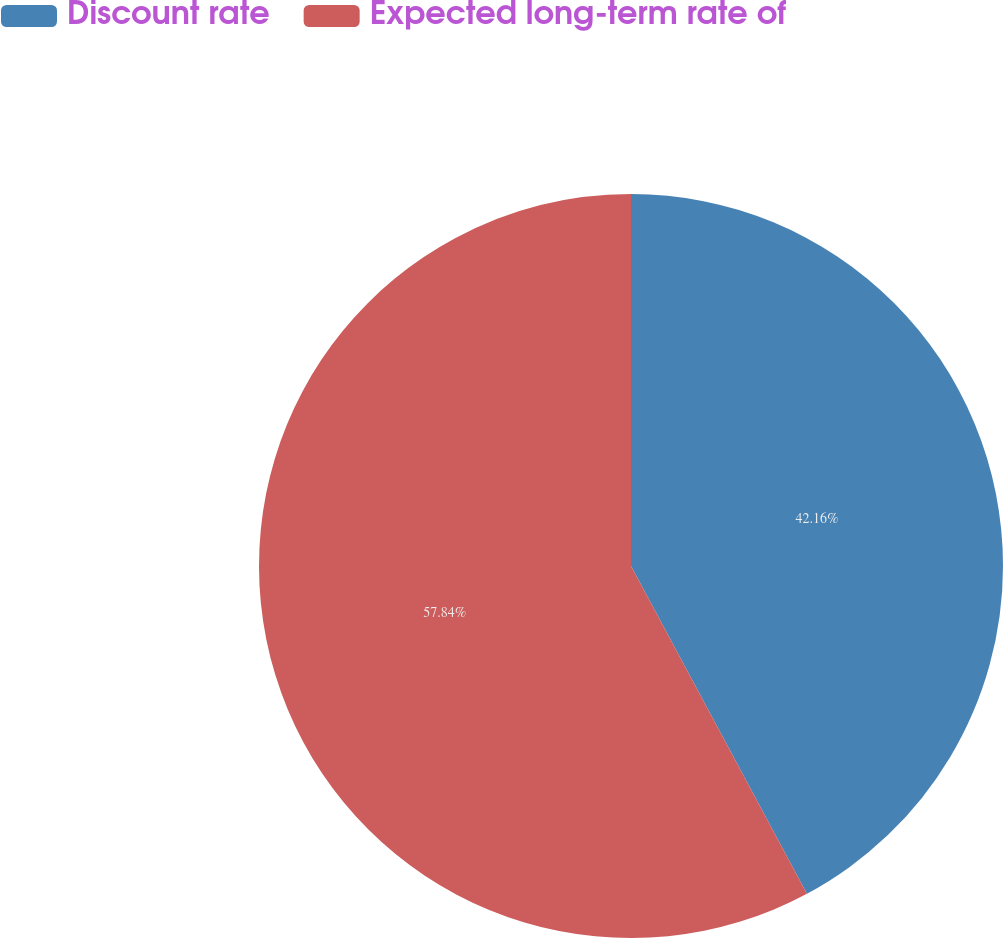Convert chart. <chart><loc_0><loc_0><loc_500><loc_500><pie_chart><fcel>Discount rate<fcel>Expected long-term rate of<nl><fcel>42.16%<fcel>57.84%<nl></chart> 